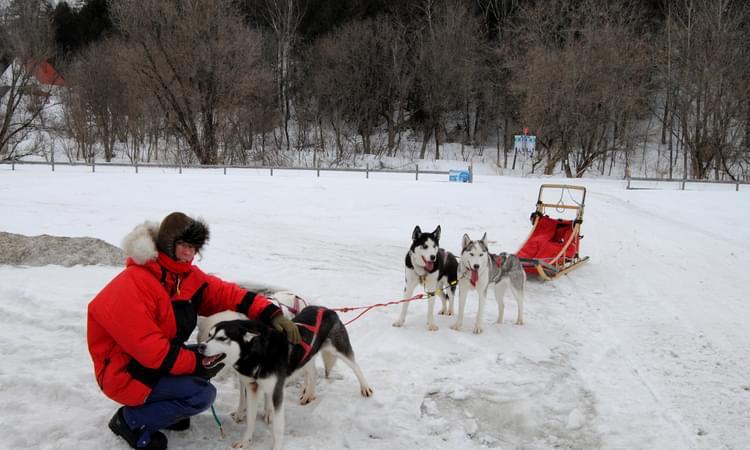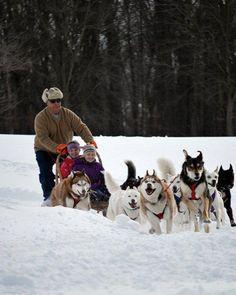The first image is the image on the left, the second image is the image on the right. Assess this claim about the two images: "In one photo dogs are running, and in the other, they are still.". Correct or not? Answer yes or no. Yes. The first image is the image on the left, the second image is the image on the right. Evaluate the accuracy of this statement regarding the images: "The person in the image on the left is wearing a red jacket.". Is it true? Answer yes or no. Yes. 